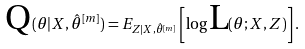Convert formula to latex. <formula><loc_0><loc_0><loc_500><loc_500>\text {Q} ( \theta | X , \hat { \theta } ^ { [ m ] } ) = E _ { Z | X , \hat { \theta } ^ { [ m ] } } \left [ \log \text {L} ( \theta ; X , Z ) \right ] .</formula> 